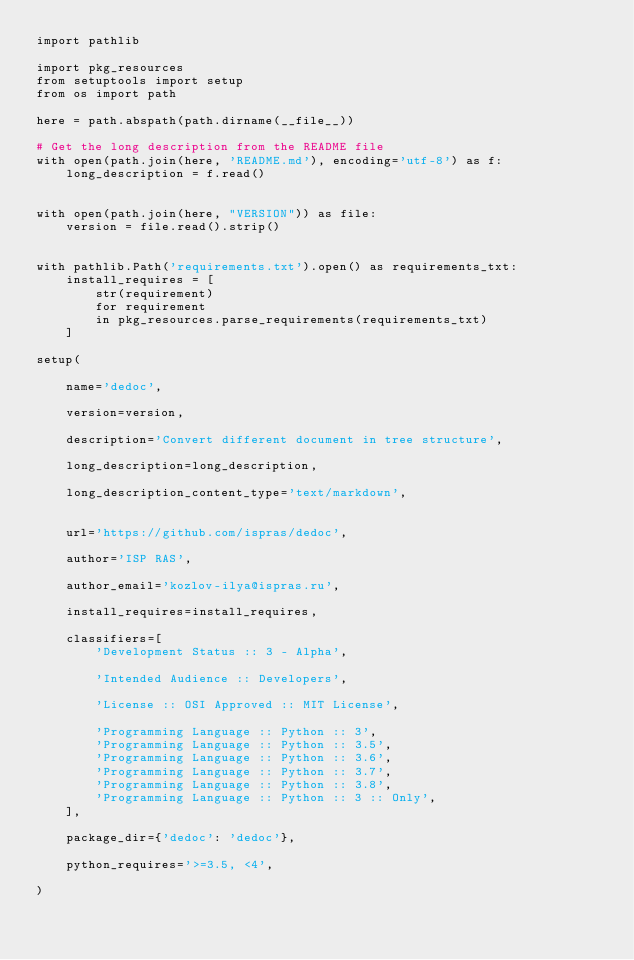<code> <loc_0><loc_0><loc_500><loc_500><_Python_>import pathlib

import pkg_resources
from setuptools import setup
from os import path

here = path.abspath(path.dirname(__file__))

# Get the long description from the README file
with open(path.join(here, 'README.md'), encoding='utf-8') as f:
    long_description = f.read()


with open(path.join(here, "VERSION")) as file:
    version = file.read().strip()


with pathlib.Path('requirements.txt').open() as requirements_txt:
    install_requires = [
        str(requirement)
        for requirement
        in pkg_resources.parse_requirements(requirements_txt)
    ]

setup(

    name='dedoc',

    version=version,

    description='Convert different document in tree structure',

    long_description=long_description,

    long_description_content_type='text/markdown',


    url='https://github.com/ispras/dedoc',

    author='ISP RAS',

    author_email='kozlov-ilya@ispras.ru',

    install_requires=install_requires,

    classifiers=[
        'Development Status :: 3 - Alpha',

        'Intended Audience :: Developers',

        'License :: OSI Approved :: MIT License',

        'Programming Language :: Python :: 3',
        'Programming Language :: Python :: 3.5',
        'Programming Language :: Python :: 3.6',
        'Programming Language :: Python :: 3.7',
        'Programming Language :: Python :: 3.8',
        'Programming Language :: Python :: 3 :: Only',
    ],

    package_dir={'dedoc': 'dedoc'},

    python_requires='>=3.5, <4',

)
</code> 